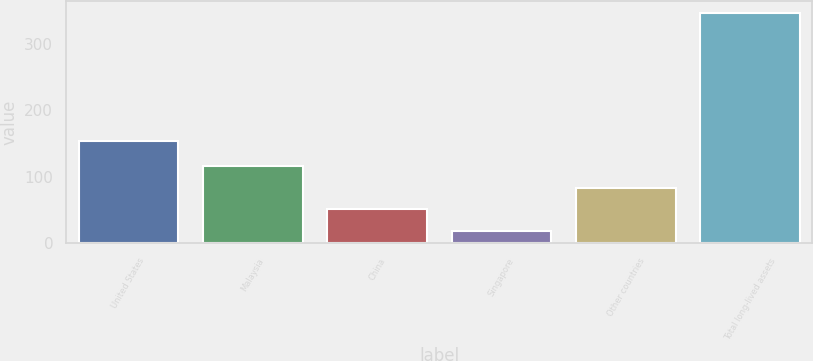<chart> <loc_0><loc_0><loc_500><loc_500><bar_chart><fcel>United States<fcel>Malaysia<fcel>China<fcel>Singapore<fcel>Other countries<fcel>Total long-lived assets<nl><fcel>153<fcel>116.4<fcel>50.8<fcel>18<fcel>83.6<fcel>346<nl></chart> 